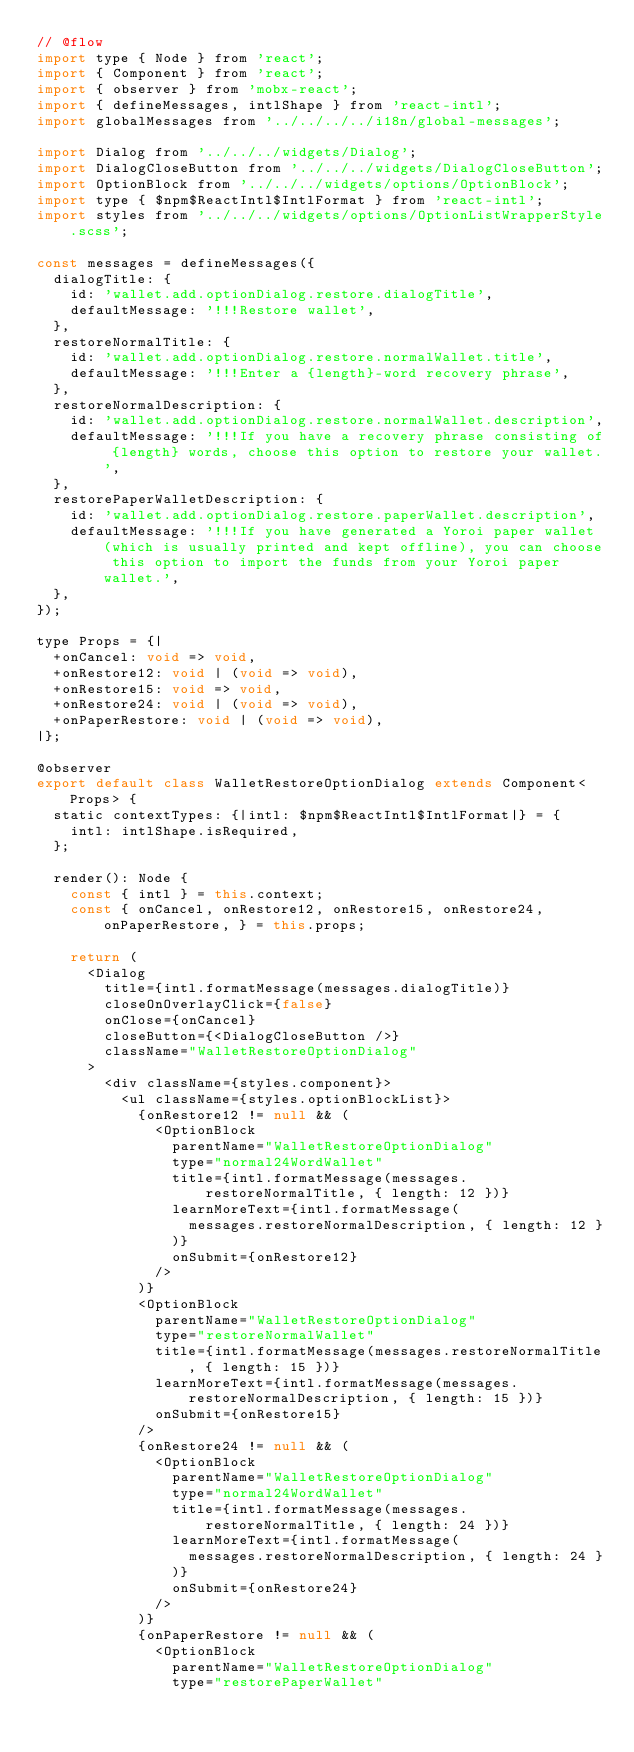Convert code to text. <code><loc_0><loc_0><loc_500><loc_500><_JavaScript_>// @flow
import type { Node } from 'react';
import { Component } from 'react';
import { observer } from 'mobx-react';
import { defineMessages, intlShape } from 'react-intl';
import globalMessages from '../../../../i18n/global-messages';

import Dialog from '../../../widgets/Dialog';
import DialogCloseButton from '../../../widgets/DialogCloseButton';
import OptionBlock from '../../../widgets/options/OptionBlock';
import type { $npm$ReactIntl$IntlFormat } from 'react-intl';
import styles from '../../../widgets/options/OptionListWrapperStyle.scss';

const messages = defineMessages({
  dialogTitle: {
    id: 'wallet.add.optionDialog.restore.dialogTitle',
    defaultMessage: '!!!Restore wallet',
  },
  restoreNormalTitle: {
    id: 'wallet.add.optionDialog.restore.normalWallet.title',
    defaultMessage: '!!!Enter a {length}-word recovery phrase',
  },
  restoreNormalDescription: {
    id: 'wallet.add.optionDialog.restore.normalWallet.description',
    defaultMessage: '!!!If you have a recovery phrase consisting of {length} words, choose this option to restore your wallet.',
  },
  restorePaperWalletDescription: {
    id: 'wallet.add.optionDialog.restore.paperWallet.description',
    defaultMessage: '!!!If you have generated a Yoroi paper wallet (which is usually printed and kept offline), you can choose this option to import the funds from your Yoroi paper wallet.',
  },
});

type Props = {|
  +onCancel: void => void,
  +onRestore12: void | (void => void),
  +onRestore15: void => void,
  +onRestore24: void | (void => void),
  +onPaperRestore: void | (void => void),
|};

@observer
export default class WalletRestoreOptionDialog extends Component<Props> {
  static contextTypes: {|intl: $npm$ReactIntl$IntlFormat|} = {
    intl: intlShape.isRequired,
  };

  render(): Node {
    const { intl } = this.context;
    const { onCancel, onRestore12, onRestore15, onRestore24, onPaperRestore, } = this.props;

    return (
      <Dialog
        title={intl.formatMessage(messages.dialogTitle)}
        closeOnOverlayClick={false}
        onClose={onCancel}
        closeButton={<DialogCloseButton />}
        className="WalletRestoreOptionDialog"
      >
        <div className={styles.component}>
          <ul className={styles.optionBlockList}>
            {onRestore12 != null && (
              <OptionBlock
                parentName="WalletRestoreOptionDialog"
                type="normal24WordWallet"
                title={intl.formatMessage(messages.restoreNormalTitle, { length: 12 })}
                learnMoreText={intl.formatMessage(
                  messages.restoreNormalDescription, { length: 12 }
                )}
                onSubmit={onRestore12}
              />
            )}
            <OptionBlock
              parentName="WalletRestoreOptionDialog"
              type="restoreNormalWallet"
              title={intl.formatMessage(messages.restoreNormalTitle, { length: 15 })}
              learnMoreText={intl.formatMessage(messages.restoreNormalDescription, { length: 15 })}
              onSubmit={onRestore15}
            />
            {onRestore24 != null && (
              <OptionBlock
                parentName="WalletRestoreOptionDialog"
                type="normal24WordWallet"
                title={intl.formatMessage(messages.restoreNormalTitle, { length: 24 })}
                learnMoreText={intl.formatMessage(
                  messages.restoreNormalDescription, { length: 24 }
                )}
                onSubmit={onRestore24}
              />
            )}
            {onPaperRestore != null && (
              <OptionBlock
                parentName="WalletRestoreOptionDialog"
                type="restorePaperWallet"</code> 